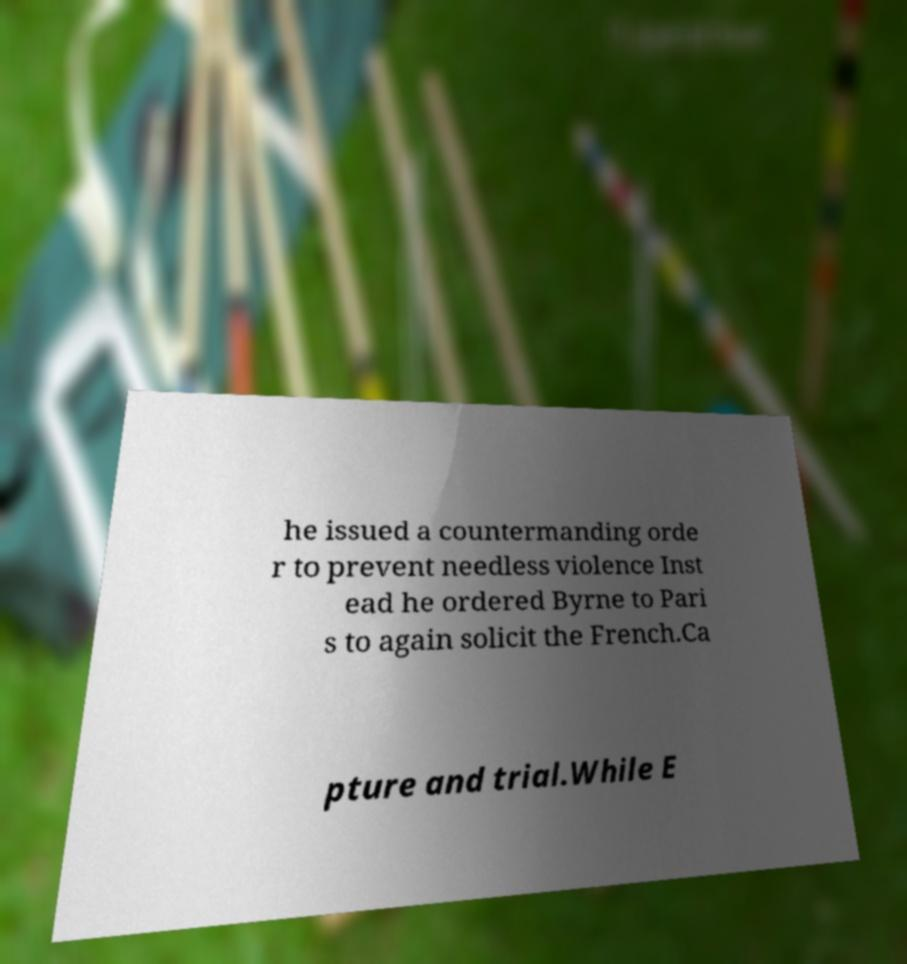What messages or text are displayed in this image? I need them in a readable, typed format. he issued a countermanding orde r to prevent needless violence Inst ead he ordered Byrne to Pari s to again solicit the French.Ca pture and trial.While E 